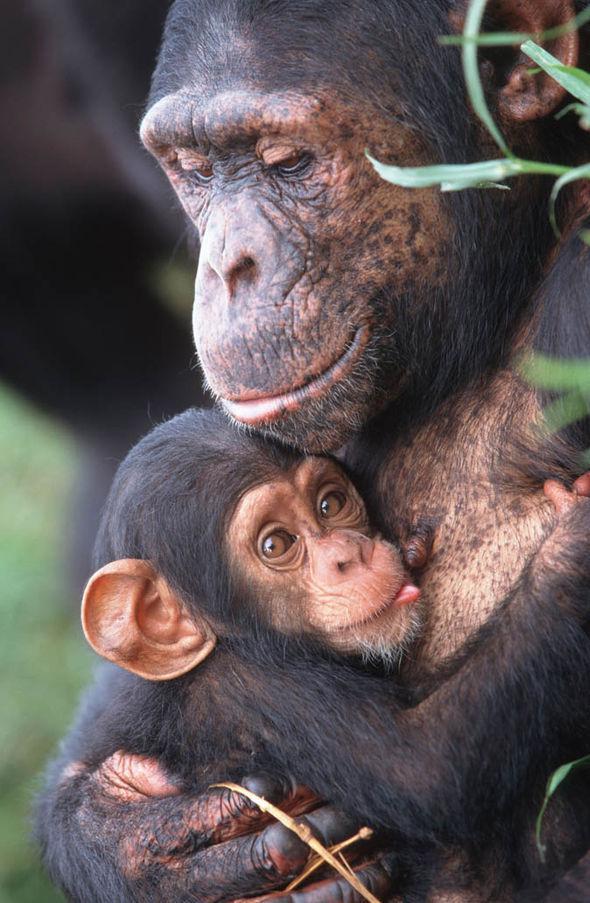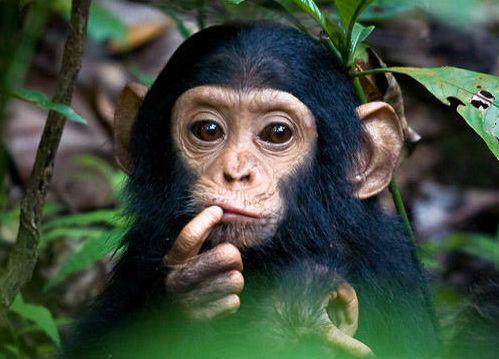The first image is the image on the left, the second image is the image on the right. For the images displayed, is the sentence "A image shows a sitting mother chimp holding a baby chimp." factually correct? Answer yes or no. Yes. The first image is the image on the left, the second image is the image on the right. For the images displayed, is the sentence "A mother chimpanzee is holding a baby chimpanzee in her arms in one or the images." factually correct? Answer yes or no. Yes. 